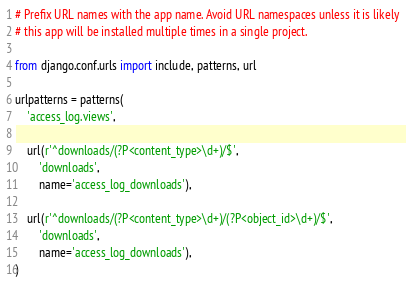Convert code to text. <code><loc_0><loc_0><loc_500><loc_500><_Python_># Prefix URL names with the app name. Avoid URL namespaces unless it is likely
# this app will be installed multiple times in a single project.

from django.conf.urls import include, patterns, url

urlpatterns = patterns(
    'access_log.views',

    url(r'^downloads/(?P<content_type>\d+)/$',
        'downloads',
        name='access_log_downloads'),

    url(r'^downloads/(?P<content_type>\d+)/(?P<object_id>\d+)/$',
        'downloads',
        name='access_log_downloads'),
)
</code> 